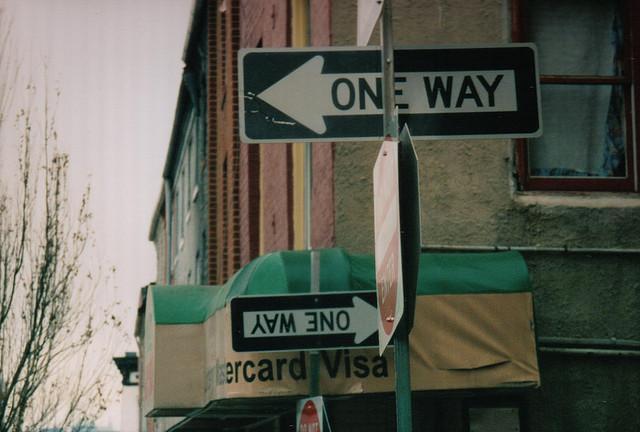How many stop signs are in the picture?
Give a very brief answer. 2. 